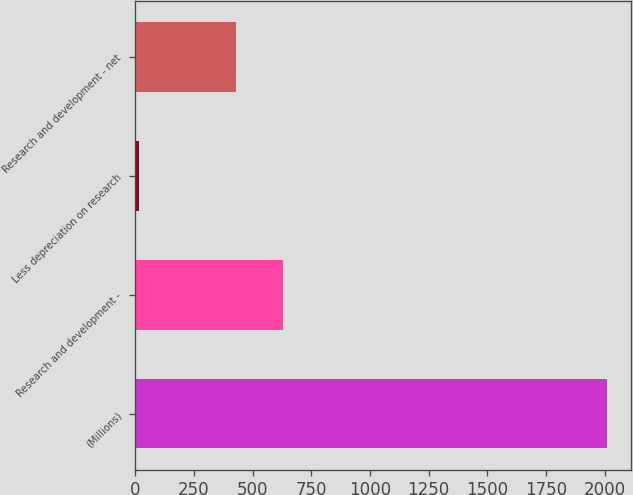<chart> <loc_0><loc_0><loc_500><loc_500><bar_chart><fcel>(Millions)<fcel>Research and development -<fcel>Less depreciation on research<fcel>Research and development - net<nl><fcel>2011<fcel>629.6<fcel>15<fcel>430<nl></chart> 